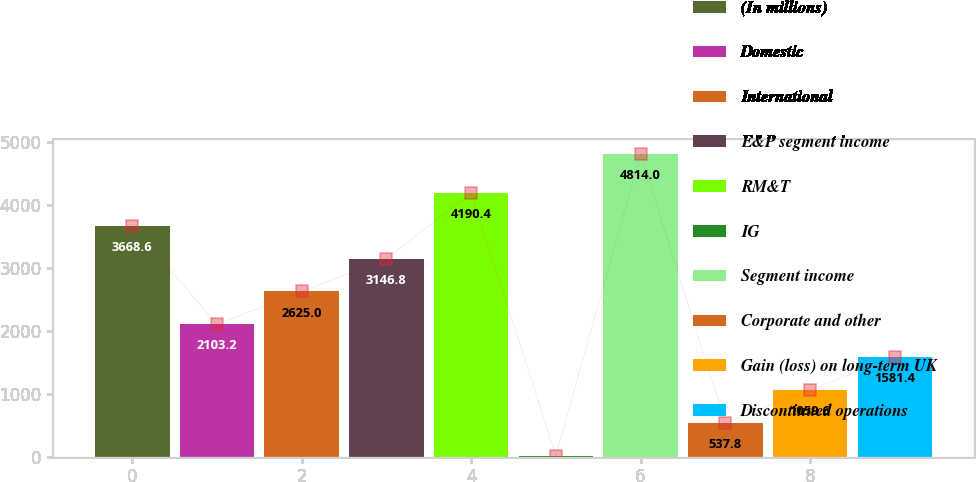Convert chart. <chart><loc_0><loc_0><loc_500><loc_500><bar_chart><fcel>(In millions)<fcel>Domestic<fcel>International<fcel>E&P segment income<fcel>RM&T<fcel>IG<fcel>Segment income<fcel>Corporate and other<fcel>Gain (loss) on long-term UK<fcel>Discontinued operations<nl><fcel>3668.6<fcel>2103.2<fcel>2625<fcel>3146.8<fcel>4190.4<fcel>16<fcel>4814<fcel>537.8<fcel>1059.6<fcel>1581.4<nl></chart> 